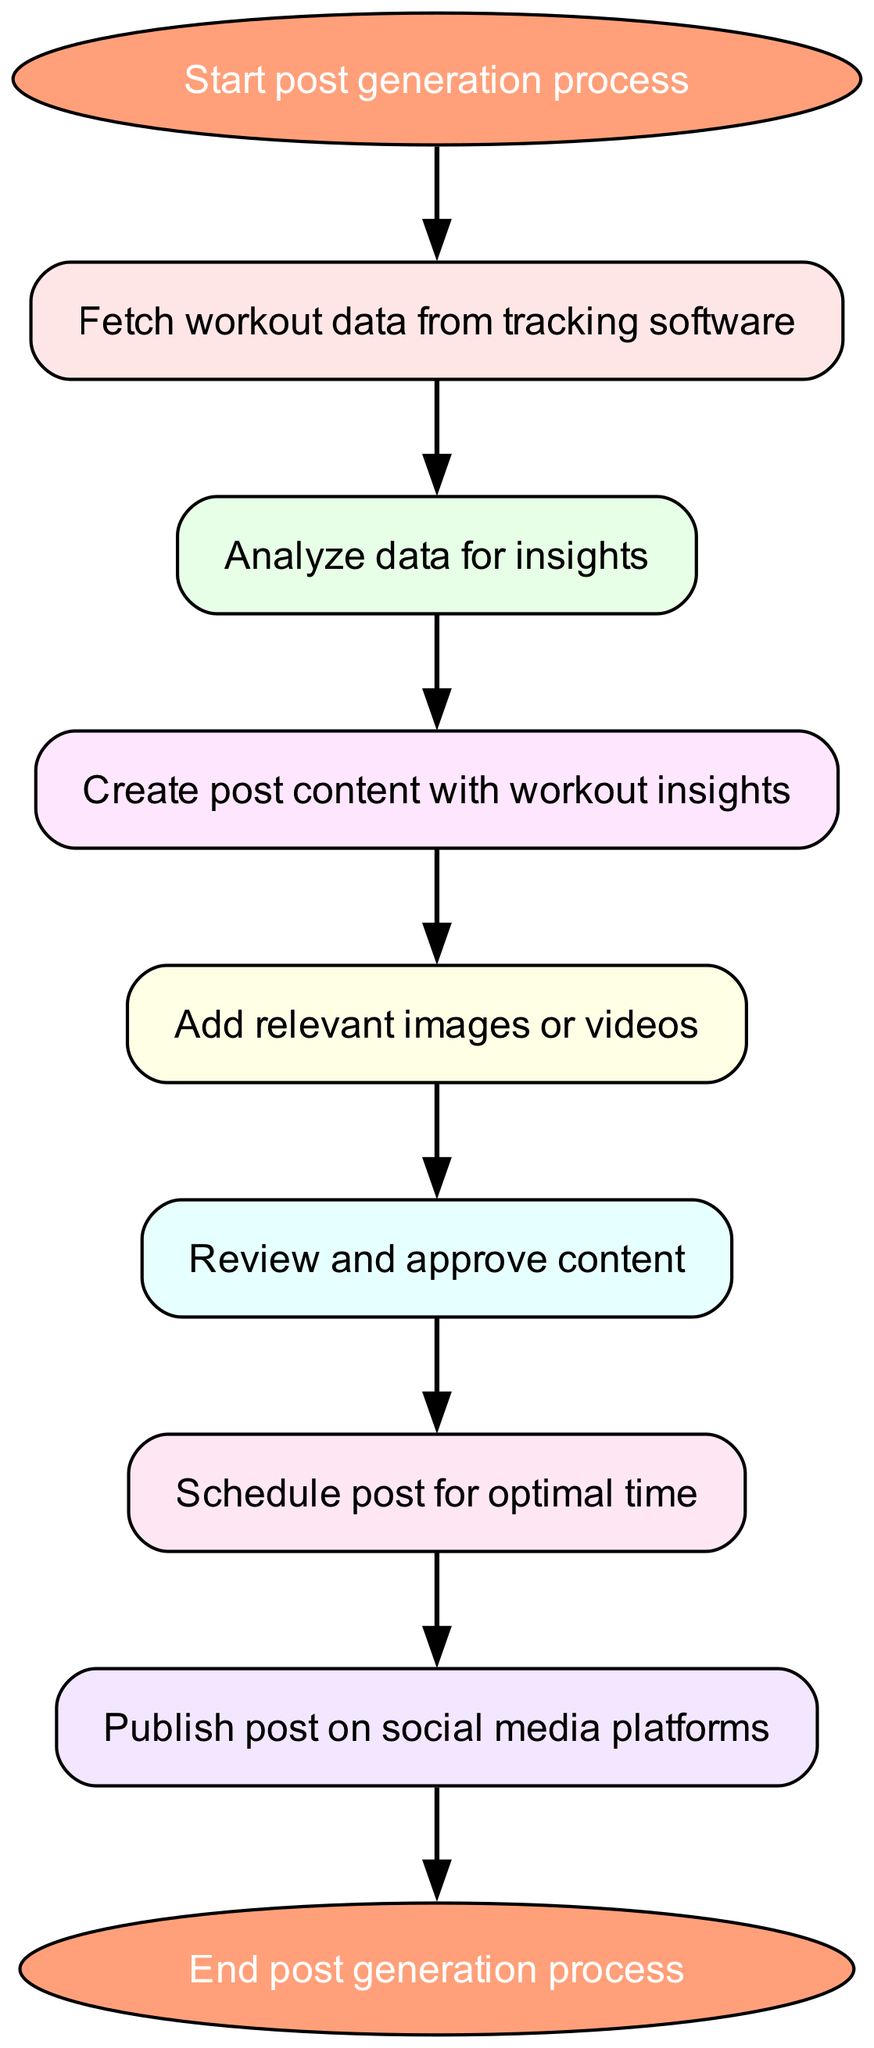What is the first step in the post generation process? The first step is labeled as "Start post generation process," which is the initial node in the diagram.
Answer: Start post generation process How many steps are involved in the workflow? The workflow consists of 8 steps, as indicated by the nodes present in the flowchart.
Answer: 8 steps What comes after analyzing data for insights? After "Analyze data for insights," the next step in the workflow is "Create post content with workout insights."
Answer: Create post content with workout insights What is the final action in this workflow? The final action in the workflow is "End post generation process," which is the last node before terminating the process.
Answer: End post generation process Which node follows scheduling the post? The node that follows "Schedule post for optimal time" is "Publish post on social media platforms," indicating the next action after scheduling.
Answer: Publish post on social media platforms What is the purpose of the "review content" node? The purpose of the "review content" node is to ensure that the created post content is approved before moving on to scheduling the post.
Answer: Ensure approval of content What type of content is added after generating post content? After generating post content, "Add relevant images or videos" is the subsequent action that enhances the post's visual appeal.
Answer: Add relevant images or videos How do you start the process of generating a post? You start the process by initiating the "Start post generation process," which is the entry point into the workflow.
Answer: Start post generation process Where does the workflow end? The workflow ends at the "End post generation process," which signifies the completion of the sequence of actions.
Answer: End post generation process 